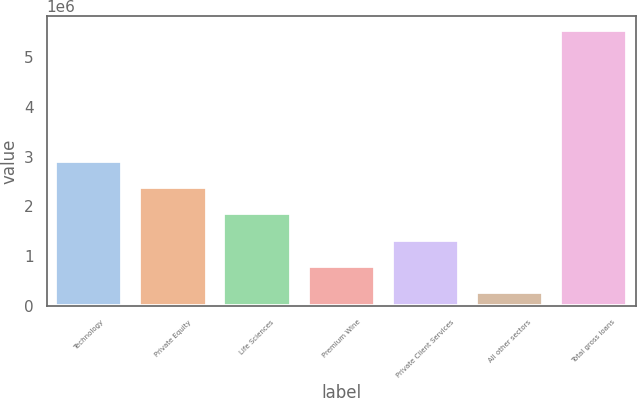Convert chart to OTSL. <chart><loc_0><loc_0><loc_500><loc_500><bar_chart><fcel>Technology<fcel>Private Equity<fcel>Life Sciences<fcel>Premium Wine<fcel>Private Client Services<fcel>All other sectors<fcel>Total gross loans<nl><fcel>2.91329e+06<fcel>2.38562e+06<fcel>1.85795e+06<fcel>802605<fcel>1.33028e+06<fcel>274935<fcel>5.55164e+06<nl></chart> 